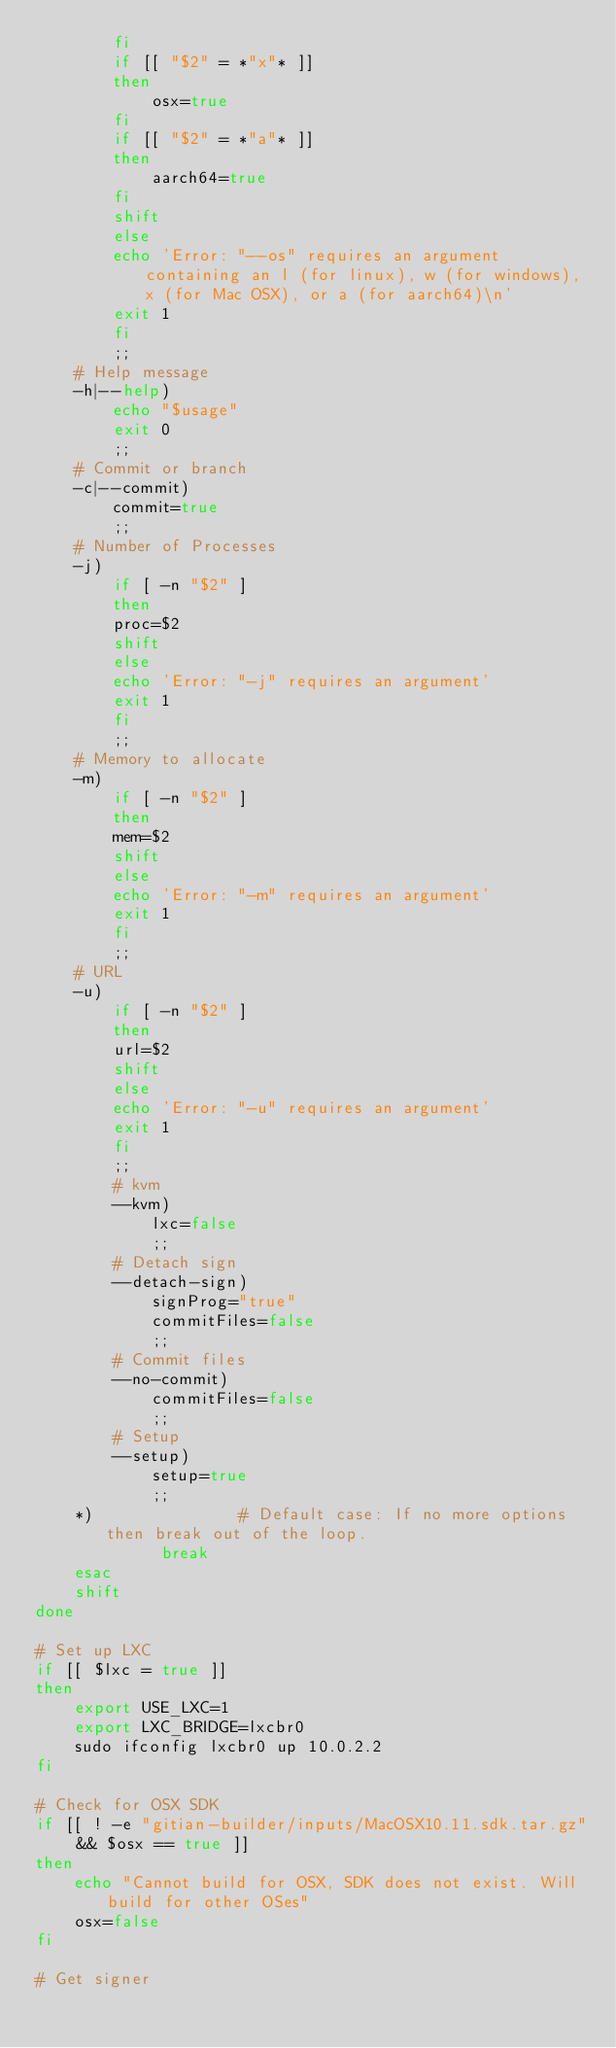<code> <loc_0><loc_0><loc_500><loc_500><_Bash_>		fi
		if [[ "$2" = *"x"* ]]
		then
		    osx=true
		fi
		if [[ "$2" = *"a"* ]]
		then
		    aarch64=true
		fi
		shift
	    else
		echo 'Error: "--os" requires an argument containing an l (for linux), w (for windows), x (for Mac OSX), or a (for aarch64)\n'
		exit 1
	    fi
	    ;;
	# Help message
	-h|--help)
	    echo "$usage"
	    exit 0
	    ;;
	# Commit or branch
	-c|--commit)
	    commit=true
	    ;;
	# Number of Processes
	-j)
	    if [ -n "$2" ]
	    then
		proc=$2
		shift
	    else
		echo 'Error: "-j" requires an argument'
		exit 1
	    fi
	    ;;
	# Memory to allocate
	-m)
	    if [ -n "$2" ]
	    then
		mem=$2
		shift
	    else
		echo 'Error: "-m" requires an argument'
		exit 1
	    fi
	    ;;
	# URL
	-u)
	    if [ -n "$2" ]
	    then
		url=$2
		shift
	    else
		echo 'Error: "-u" requires an argument'
		exit 1
	    fi
	    ;;
        # kvm
        --kvm)
            lxc=false
            ;;
        # Detach sign
        --detach-sign)
            signProg="true"
            commitFiles=false
            ;;
        # Commit files
        --no-commit)
            commitFiles=false
            ;;
        # Setup
        --setup)
            setup=true
            ;;
	*)               # Default case: If no more options then break out of the loop.
             break
    esac
    shift
done

# Set up LXC
if [[ $lxc = true ]]
then
    export USE_LXC=1
    export LXC_BRIDGE=lxcbr0
    sudo ifconfig lxcbr0 up 10.0.2.2
fi

# Check for OSX SDK
if [[ ! -e "gitian-builder/inputs/MacOSX10.11.sdk.tar.gz" && $osx == true ]]
then
    echo "Cannot build for OSX, SDK does not exist. Will build for other OSes"
    osx=false
fi

# Get signer</code> 